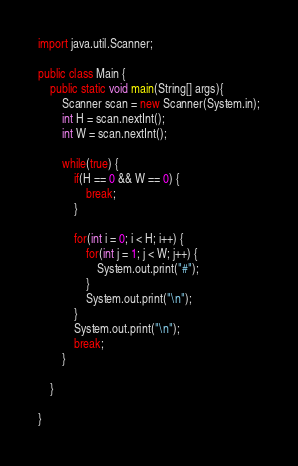Convert code to text. <code><loc_0><loc_0><loc_500><loc_500><_Java_>import java.util.Scanner;

public class Main {
	public static void main(String[] args){
		Scanner scan = new Scanner(System.in);
		int H = scan.nextInt();
		int W = scan.nextInt();

		while(true) {
			if(H == 0 && W == 0) {
				break;
			}

			for(int i = 0; i < H; i++) {
				for(int j = 1; j < W; j++) {
					System.out.print("#");
				}
				System.out.print("\n");
			}
			System.out.print("\n");
			break;
		}

	}

}</code> 